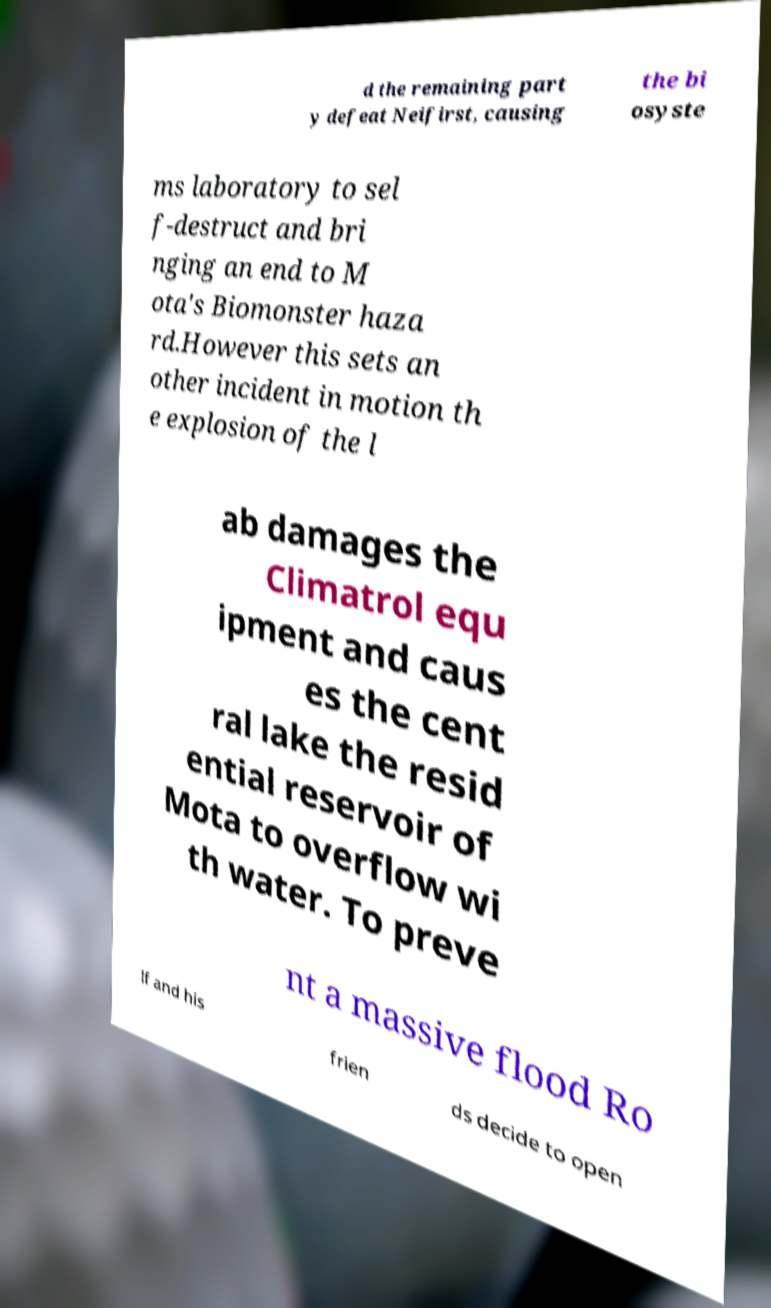Can you accurately transcribe the text from the provided image for me? d the remaining part y defeat Neifirst, causing the bi osyste ms laboratory to sel f-destruct and bri nging an end to M ota's Biomonster haza rd.However this sets an other incident in motion th e explosion of the l ab damages the Climatrol equ ipment and caus es the cent ral lake the resid ential reservoir of Mota to overflow wi th water. To preve nt a massive flood Ro lf and his frien ds decide to open 